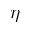Convert formula to latex. <formula><loc_0><loc_0><loc_500><loc_500>\eta</formula> 